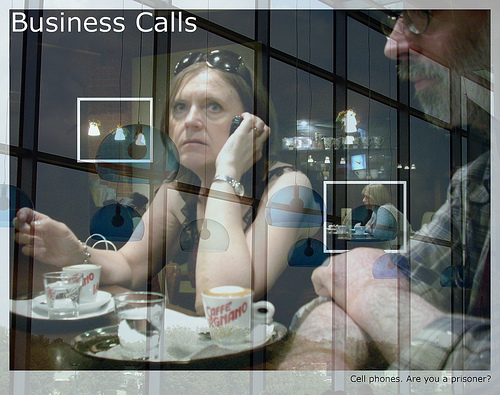Can you describe the overall mood of the image? The overall mood of the image appears to be serious and contemplative, likely reflecting the nature of a business call. What can you infer about the relationship between the woman and the man? They seem to be colleagues, possibly discussing business matters. The serious expressions suggest the conversation is of importance. If you could step into the image, what would you like to ask or say to the woman? I might ask the woman if she needs any additional information or assistance with her current conversation, as she seems quite focused and might appreciate support. 